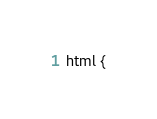Convert code to text. <code><loc_0><loc_0><loc_500><loc_500><_CSS_>html {</code> 